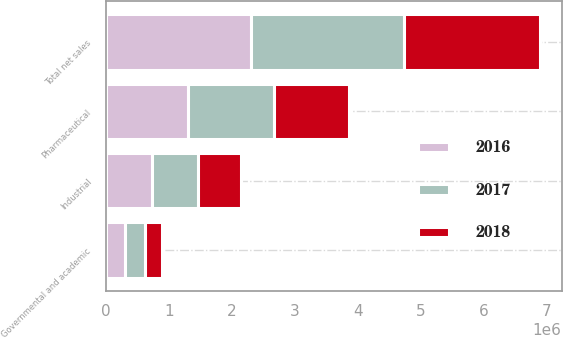Convert chart to OTSL. <chart><loc_0><loc_0><loc_500><loc_500><stacked_bar_chart><ecel><fcel>Pharmaceutical<fcel>Industrial<fcel>Governmental and academic<fcel>Total net sales<nl><fcel>2017<fcel>1.36573e+06<fcel>737144<fcel>317054<fcel>2.41993e+06<nl><fcel>2016<fcel>1.29467e+06<fcel>721088<fcel>293322<fcel>2.30908e+06<nl><fcel>2018<fcel>1.20632e+06<fcel>690119<fcel>270988<fcel>2.16742e+06<nl></chart> 